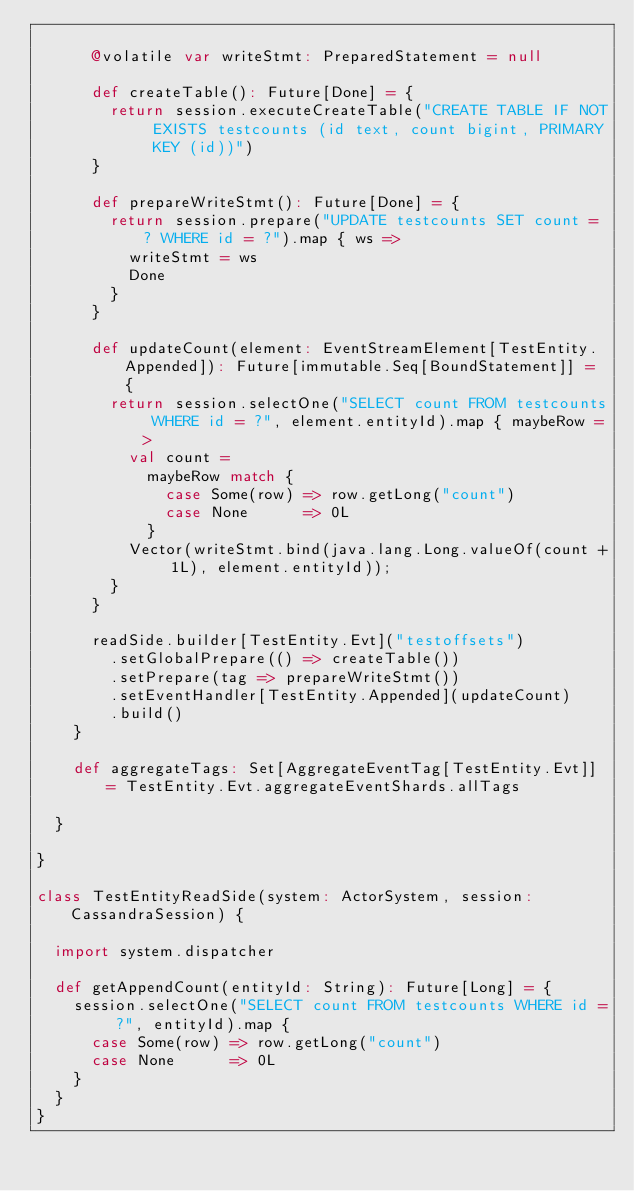<code> <loc_0><loc_0><loc_500><loc_500><_Scala_>
      @volatile var writeStmt: PreparedStatement = null

      def createTable(): Future[Done] = {
        return session.executeCreateTable("CREATE TABLE IF NOT EXISTS testcounts (id text, count bigint, PRIMARY KEY (id))")
      }

      def prepareWriteStmt(): Future[Done] = {
        return session.prepare("UPDATE testcounts SET count = ? WHERE id = ?").map { ws =>
          writeStmt = ws
          Done
        }
      }

      def updateCount(element: EventStreamElement[TestEntity.Appended]): Future[immutable.Seq[BoundStatement]] = {
        return session.selectOne("SELECT count FROM testcounts WHERE id = ?", element.entityId).map { maybeRow =>
          val count =
            maybeRow match {
              case Some(row) => row.getLong("count")
              case None      => 0L
            }
          Vector(writeStmt.bind(java.lang.Long.valueOf(count + 1L), element.entityId));
        }
      }

      readSide.builder[TestEntity.Evt]("testoffsets")
        .setGlobalPrepare(() => createTable())
        .setPrepare(tag => prepareWriteStmt())
        .setEventHandler[TestEntity.Appended](updateCount)
        .build()
    }

    def aggregateTags: Set[AggregateEventTag[TestEntity.Evt]] = TestEntity.Evt.aggregateEventShards.allTags

  }

}

class TestEntityReadSide(system: ActorSystem, session: CassandraSession) {

  import system.dispatcher

  def getAppendCount(entityId: String): Future[Long] = {
    session.selectOne("SELECT count FROM testcounts WHERE id = ?", entityId).map {
      case Some(row) => row.getLong("count")
      case None      => 0L
    }
  }
}
</code> 